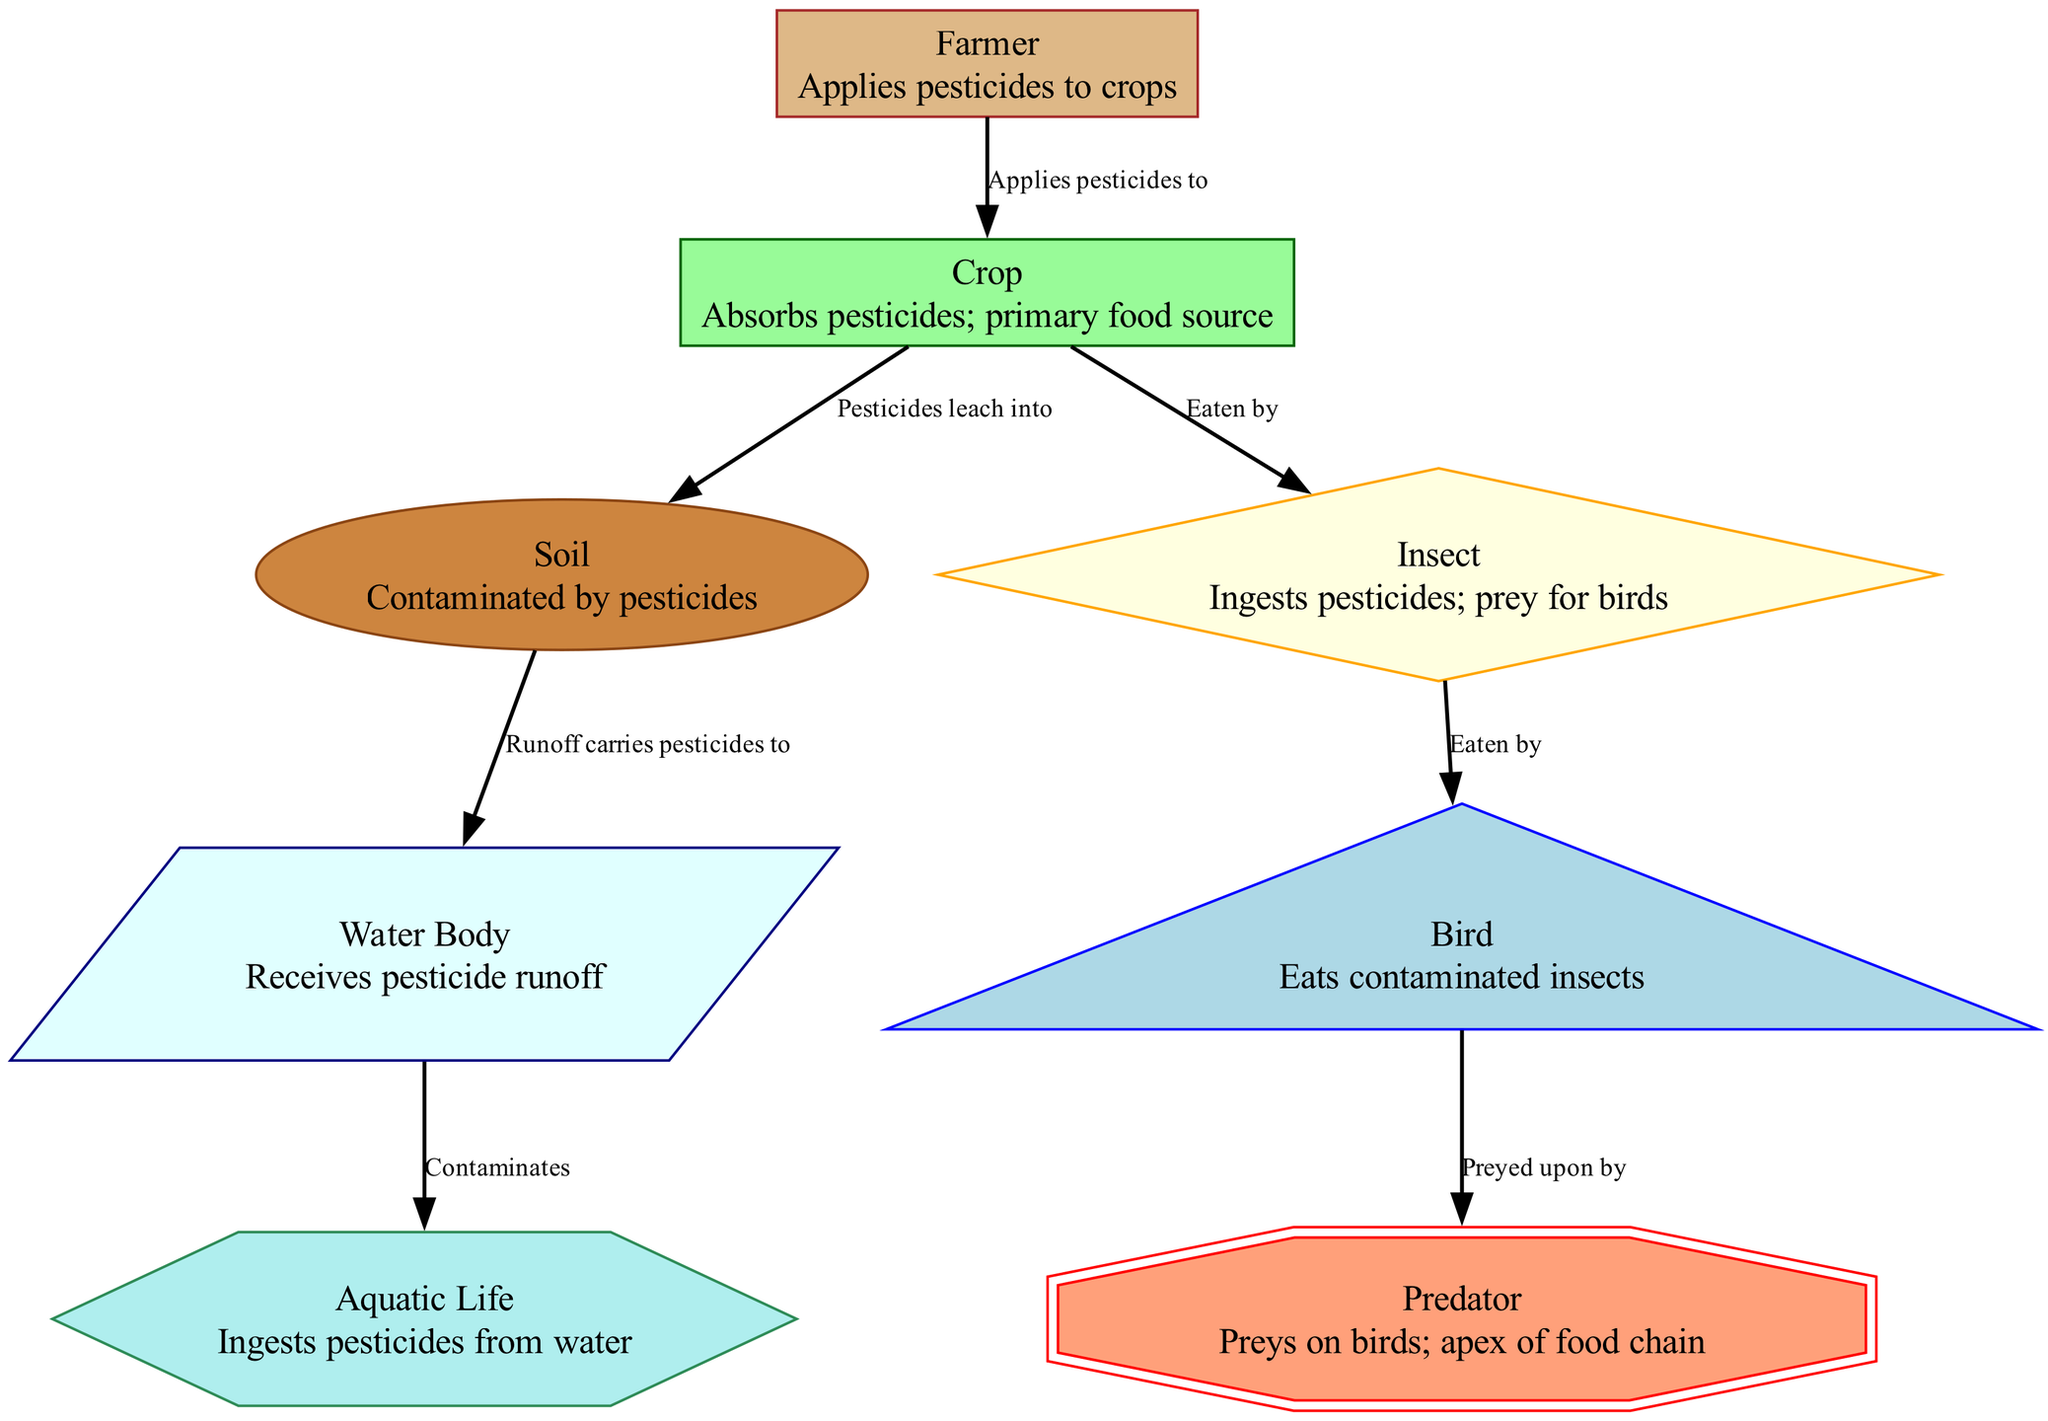What is the apex predator in the food chain? The apex of the food chain is represented by the "Predator" node, which is shown at the top of the diagram, indicating it is the highest trophic level.
Answer: Predator How many nodes are present in the diagram? The diagram lists a total of 8 distinct nodes: Farmer, Crop, Soil, Insect, Bird, Predator, Water Body, and Aquatic Life. Therefore, the total number of nodes is 8.
Answer: 8 What do insects ingest as a result of pesticide use? The diagram indicates that insects are defined as species which ingest pesticides from the contaminated crops, thus the answer is pesticides.
Answer: Pesticides Which node receives pesticide runoff from the soil? It can be seen in the diagram that the "Water Body" node is directly linked to the "Soil" node, with a directed edge indicating that the runoff from the soil carries pesticides directly to the water body.
Answer: Water Body What is the relationship between birds and predators? The diagram shows a directional edge from "Bird" to "Predator," indicating that predators prey on birds, establishing a relationship of predator-prey between these two nodes.
Answer: Preyed upon by What impact do pesticides have on aquatic life? According to the diagram, the "Aquatic Life" node is affected by the "Water Body" node, which is contaminated by pesticides — hence, the impact described is that aquatic life ingests pesticides from the water.
Answer: Ingests pesticides Which component absorbs pesticides as a primary food source? The "Crop" node is specifically labeled as absorbing pesticides and serves as the primary food source for insects, making it the answer to this question.
Answer: Crop What type of contaminants are found in soil as per the diagram? The explanation within the diagram states that pesticides contaminate the "Soil" node, confirming that the type of contaminants found is pesticides.
Answer: Pesticides How do pesticides affect the food chain from the farmer to the predator? The diagram illustrates a clear sequence showing how a farmer applies pesticides to crops, which leach into soil, affect insects, are consumed by birds, and ultimately impact predators. This chain represents the cascading effects of pesticides throughout the food chain.
Answer: Cascading effects 